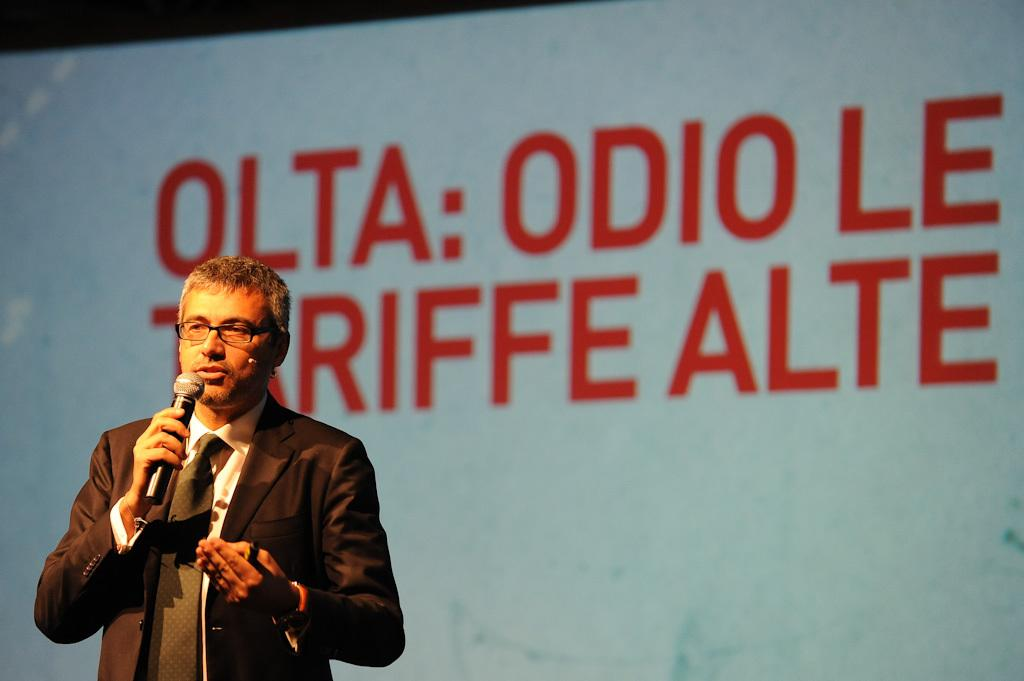What is the main object in the image? There is a screen in the image. Who or what is in front of the screen? There is a person in the image. What is the person wearing? The person is wearing a black color jacket. What is the person holding? The person is holding a mic. How many hands are visible on the shelf in the image? There is no shelf present in the image, and therefore no hands can be seen on a shelf. 